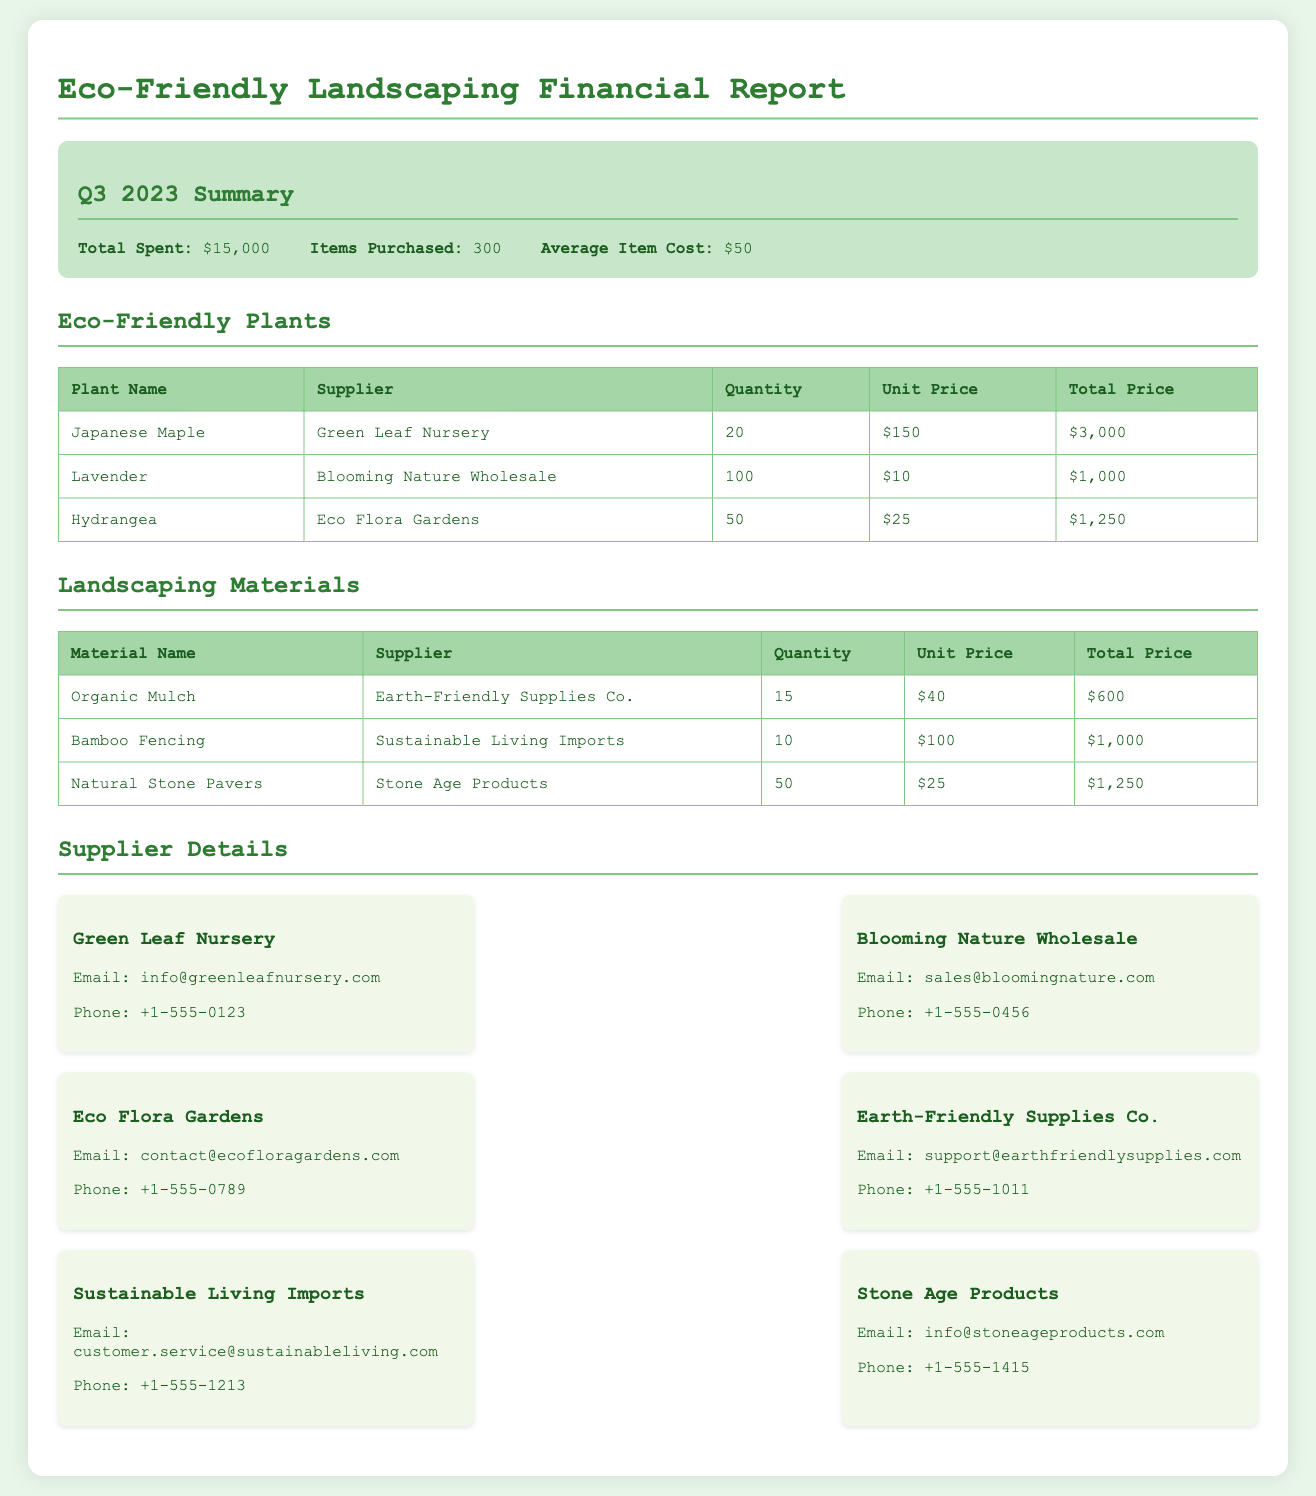What is the total amount spent on purchases? The total amount spent is provided in the summary of the document as $15,000.
Answer: $15,000 How many items were purchased in total? The summary section notes that a total of 300 items were purchased last quarter.
Answer: 300 What is the total revenue from the Japanese Maple? The total revenue for the Japanese Maple is calculated as the unit price ($150) times the quantity (20), which is $3,000.
Answer: $3,000 Who is the supplier of Lavender? The document specifies that Lavender was supplied by Blooming Nature Wholesale.
Answer: Blooming Nature Wholesale How many Natural Stone Pavers were purchased? The quantity of Natural Stone Pavers is listed in the landscaping materials section as 50.
Answer: 50 What is the average cost of an item? The document states that the average item cost is $50 in the summary section.
Answer: $50 Which supplier provides Organic Mulch? The supplier for Organic Mulch is listed as Earth-Friendly Supplies Co. in the landscaping materials table.
Answer: Earth-Friendly Supplies Co What is the unit price of Bamboo Fencing? The unit price for Bamboo Fencing is stated in the document as $100.
Answer: $100 What is the email for Eco Flora Gardens? The email address for Eco Flora Gardens is provided in the supplier details as contact@ecofloragardens.com.
Answer: contact@ecofloragardens.com 